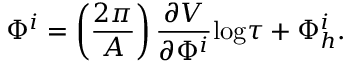<formula> <loc_0><loc_0><loc_500><loc_500>\Phi ^ { i } = \left ( \frac { 2 \pi } { A } \right ) \frac { \partial V } { \partial \Phi ^ { i } } \log \tau + \Phi _ { h } ^ { i } .</formula> 